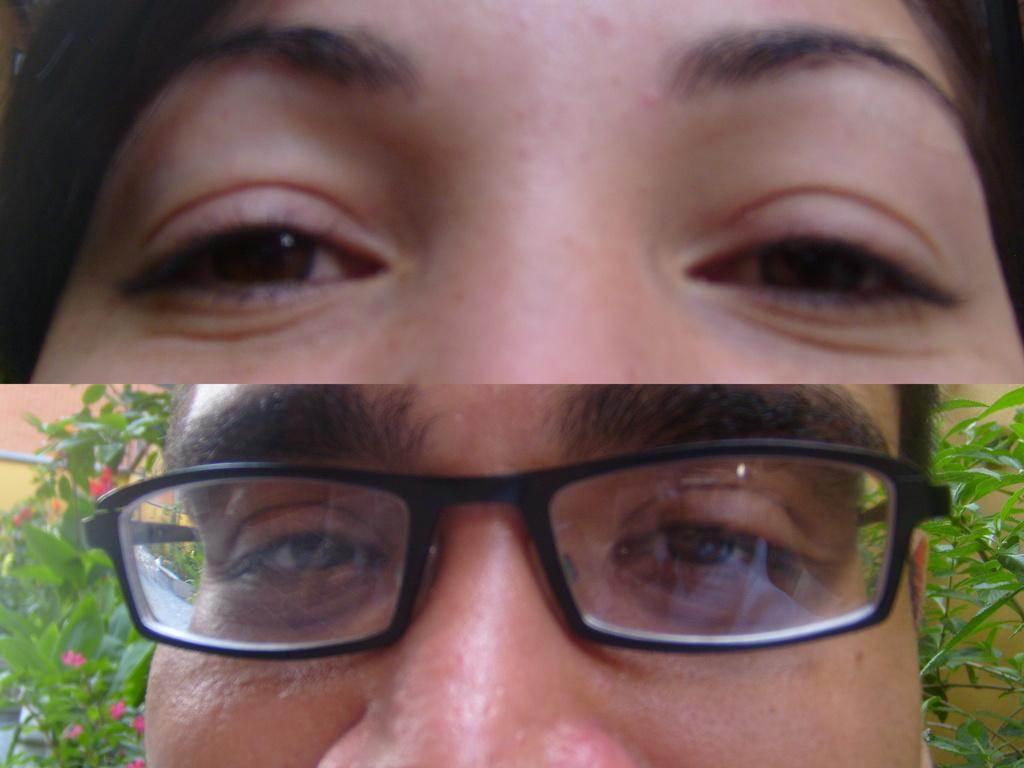How is the image composed? The image is a collage of two parts. What can be seen in the top part of the collage? At the top of the collage, there is a face of a person. What is depicted in the bottom part of the collage? At the bottom of the collage, there is a person with spectacles. What type of vegetation is visible behind the person with spectacles? Flowers and trees are visible behind the person with spectacles. What event is taking place in the image? The image does not depict an event; it is a collage of two parts featuring a face and a person with spectacles. What is the current state of the person with spectacles in the image? The image does not provide information about the current state of the person with spectacles; it only shows their appearance. 